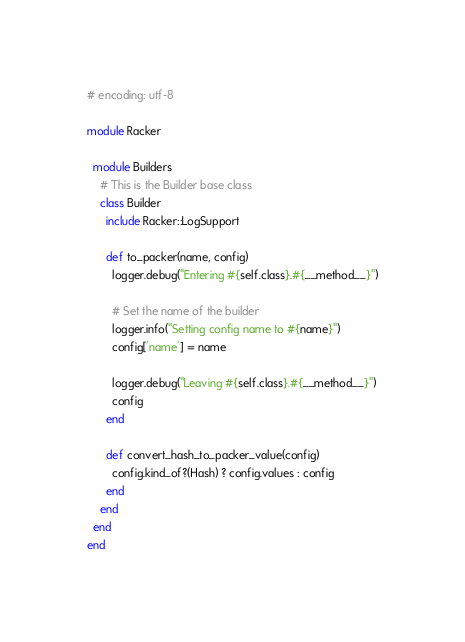<code> <loc_0><loc_0><loc_500><loc_500><_Ruby_># encoding: utf-8

module Racker

  module Builders
    # This is the Builder base class
    class Builder
      include Racker::LogSupport

      def to_packer(name, config)
        logger.debug("Entering #{self.class}.#{__method__}")

        # Set the name of the builder
        logger.info("Setting config name to #{name}")
        config['name'] = name

        logger.debug("Leaving #{self.class}.#{__method__}")
        config
      end

      def convert_hash_to_packer_value(config)
        config.kind_of?(Hash) ? config.values : config
      end
    end
  end
end
</code> 